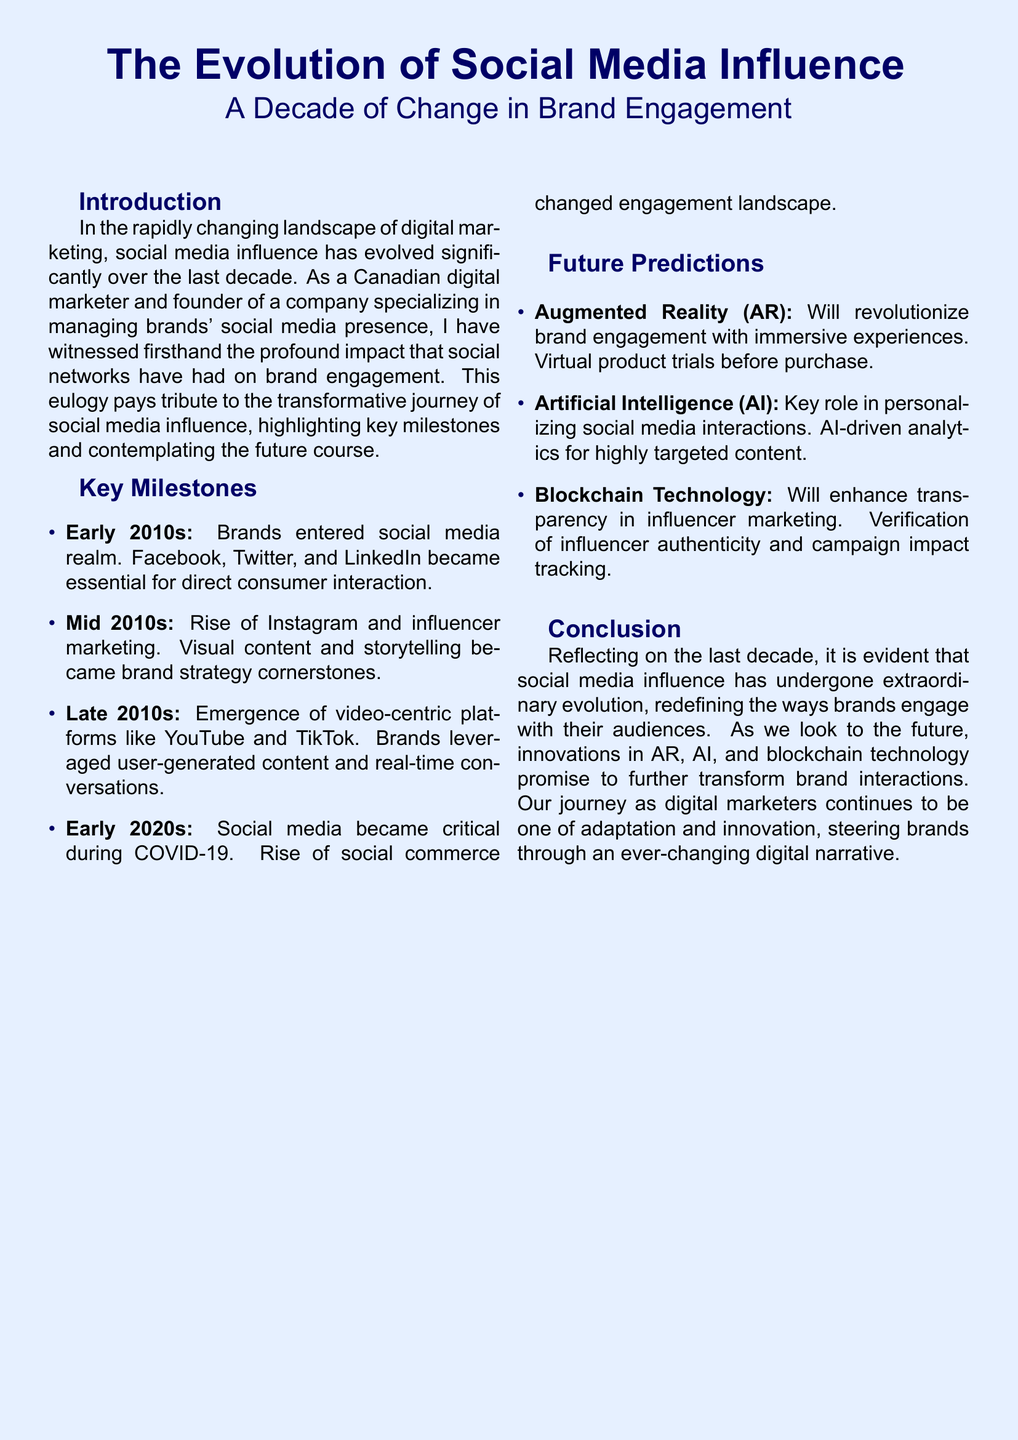What were the key social media platforms in the early 2010s? The document lists Facebook, Twitter, and LinkedIn as essential for direct consumer interaction during the early 2010s.
Answer: Facebook, Twitter, and LinkedIn What became critical during COVID-19? It states that social media became critical during COVID-19, indicating a significant shift in engagement.
Answer: Social media What technology will enhance transparency in influencer marketing? The document mentions blockchain technology as a means to enhance transparency in influencer marketing.
Answer: Blockchain Technology In what decade did brands enter the social media realm? The document references the early 2010s as the decade when brands began entering the social media realm.
Answer: Early 2010s What is a forecasted technology that will revolutionize brand engagement? The document predicts that augmented reality (AR) will revolutionize brand engagement with immersive experiences.
Answer: Augmented Reality (AR) What role will AI play in future social media interactions? According to the document, AI will play a key role in personalizing social media interactions.
Answer: Personalizing social media interactions Which platforms emerged in the late 2010s? The document highlights YouTube and TikTok as video-centric platforms that emerged in the late 2010s.
Answer: YouTube and TikTok What cornerstone strategy did visual content become in the mid 2010s? The document states that visual content and storytelling became brand strategy cornerstones in the mid 2010s.
Answer: Brand strategy cornerstones 